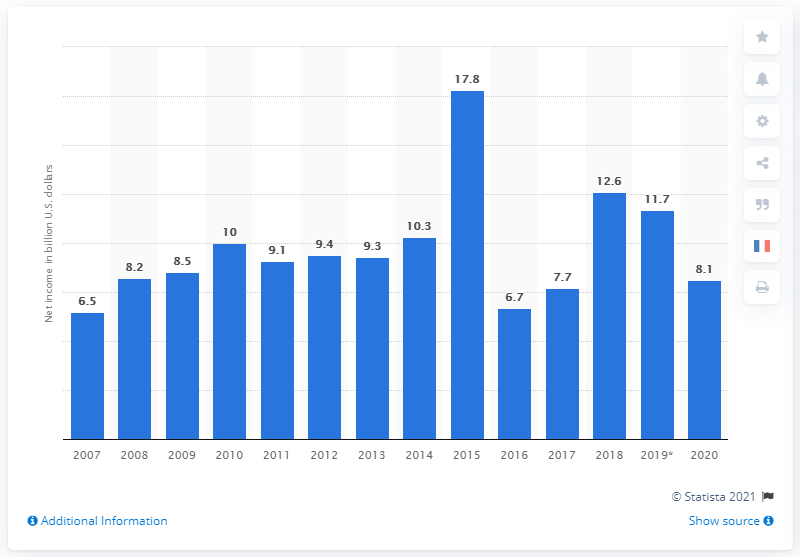Highlight a few significant elements in this photo. In 2019, Novartis AG's net income was 8.1 billion US dollars. 